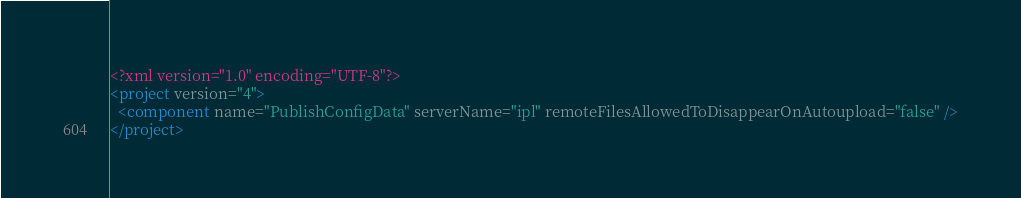<code> <loc_0><loc_0><loc_500><loc_500><_XML_><?xml version="1.0" encoding="UTF-8"?>
<project version="4">
  <component name="PublishConfigData" serverName="ipl" remoteFilesAllowedToDisappearOnAutoupload="false" />
</project></code> 